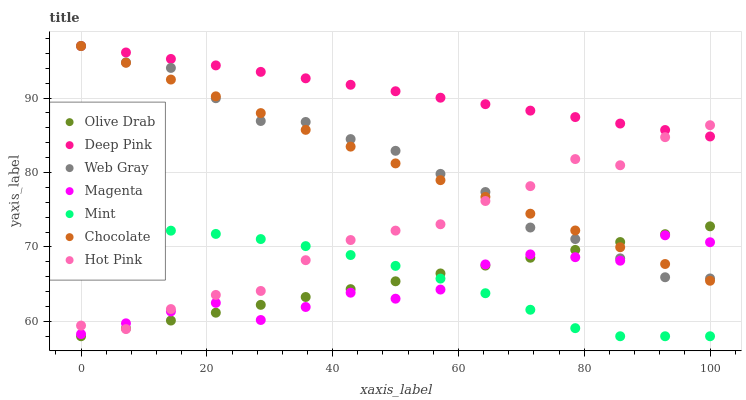Does Magenta have the minimum area under the curve?
Answer yes or no. Yes. Does Deep Pink have the maximum area under the curve?
Answer yes or no. Yes. Does Hot Pink have the minimum area under the curve?
Answer yes or no. No. Does Hot Pink have the maximum area under the curve?
Answer yes or no. No. Is Deep Pink the smoothest?
Answer yes or no. Yes. Is Hot Pink the roughest?
Answer yes or no. Yes. Is Chocolate the smoothest?
Answer yes or no. No. Is Chocolate the roughest?
Answer yes or no. No. Does Mint have the lowest value?
Answer yes or no. Yes. Does Hot Pink have the lowest value?
Answer yes or no. No. Does Web Gray have the highest value?
Answer yes or no. Yes. Does Hot Pink have the highest value?
Answer yes or no. No. Is Mint less than Deep Pink?
Answer yes or no. Yes. Is Chocolate greater than Mint?
Answer yes or no. Yes. Does Magenta intersect Chocolate?
Answer yes or no. Yes. Is Magenta less than Chocolate?
Answer yes or no. No. Is Magenta greater than Chocolate?
Answer yes or no. No. Does Mint intersect Deep Pink?
Answer yes or no. No. 